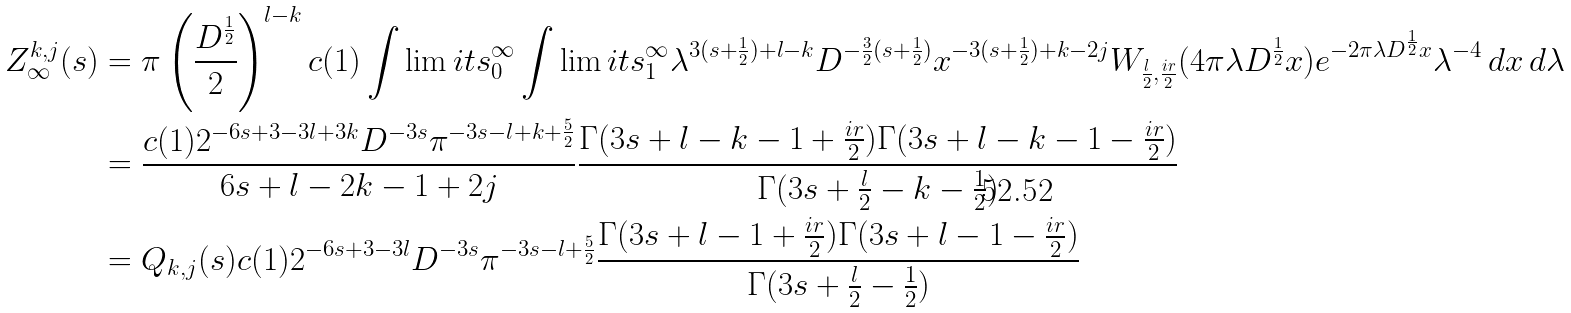<formula> <loc_0><loc_0><loc_500><loc_500>Z _ { \infty } ^ { k , j } ( s ) & = \pi \left ( \frac { D ^ { \frac { 1 } { 2 } } } 2 \right ) ^ { l - k } c ( 1 ) \int \lim i t s _ { 0 } ^ { \infty } \int \lim i t s _ { 1 } ^ { \infty } \lambda ^ { 3 ( s + \frac { 1 } { 2 } ) + l - k } D ^ { - \frac { 3 } { 2 } ( s + \frac { 1 } { 2 } ) } x ^ { - 3 ( s + \frac { 1 } { 2 } ) + k - 2 j } W _ { \frac { l } { 2 } , \frac { i r } 2 } ( 4 \pi \lambda D ^ { \frac { 1 } { 2 } } x ) e ^ { - 2 \pi \lambda D ^ { \frac { 1 } { 2 } } x } \lambda ^ { - 4 } \, d x \, d \lambda \\ & = \frac { c ( 1 ) 2 ^ { - 6 s + 3 - 3 l + 3 k } D ^ { - 3 s } \pi ^ { - 3 s - l + k + \frac { 5 } { 2 } } } { 6 s + l - 2 k - 1 + 2 j } \frac { \Gamma ( 3 s + l - k - 1 + \frac { i r } 2 ) \Gamma ( 3 s + l - k - 1 - \frac { i r } 2 ) } { \Gamma ( 3 s + \frac { l } { 2 } - k - \frac { 1 } { 2 } ) } \\ & = Q _ { k , j } ( s ) c ( 1 ) 2 ^ { - 6 s + 3 - 3 l } D ^ { - 3 s } \pi ^ { - 3 s - l + \frac { 5 } { 2 } } \frac { \Gamma ( 3 s + l - 1 + \frac { i r } 2 ) \Gamma ( 3 s + l - 1 - \frac { i r } 2 ) } { \Gamma ( 3 s + \frac { l } { 2 } - \frac { 1 } { 2 } ) }</formula> 